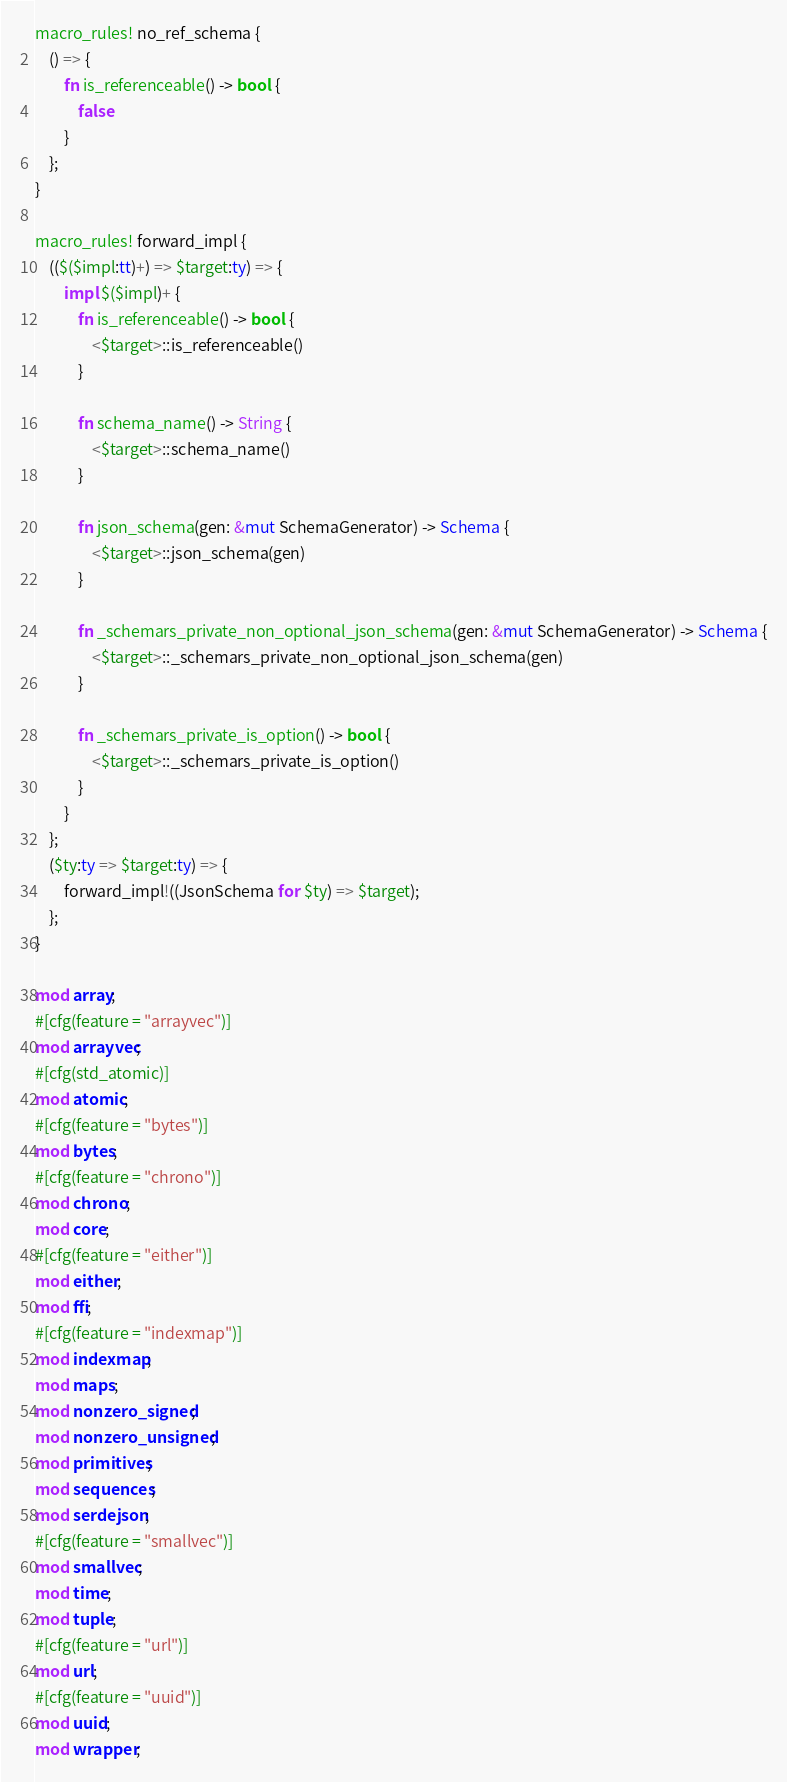<code> <loc_0><loc_0><loc_500><loc_500><_Rust_>macro_rules! no_ref_schema {
    () => {
        fn is_referenceable() -> bool {
            false
        }
    };
}

macro_rules! forward_impl {
    (($($impl:tt)+) => $target:ty) => {
        impl $($impl)+ {
            fn is_referenceable() -> bool {
                <$target>::is_referenceable()
            }

            fn schema_name() -> String {
                <$target>::schema_name()
            }

            fn json_schema(gen: &mut SchemaGenerator) -> Schema {
                <$target>::json_schema(gen)
            }

            fn _schemars_private_non_optional_json_schema(gen: &mut SchemaGenerator) -> Schema {
                <$target>::_schemars_private_non_optional_json_schema(gen)
            }

            fn _schemars_private_is_option() -> bool {
                <$target>::_schemars_private_is_option()
            }
        }
    };
    ($ty:ty => $target:ty) => {
        forward_impl!((JsonSchema for $ty) => $target);
    };
}

mod array;
#[cfg(feature = "arrayvec")]
mod arrayvec;
#[cfg(std_atomic)]
mod atomic;
#[cfg(feature = "bytes")]
mod bytes;
#[cfg(feature = "chrono")]
mod chrono;
mod core;
#[cfg(feature = "either")]
mod either;
mod ffi;
#[cfg(feature = "indexmap")]
mod indexmap;
mod maps;
mod nonzero_signed;
mod nonzero_unsigned;
mod primitives;
mod sequences;
mod serdejson;
#[cfg(feature = "smallvec")]
mod smallvec;
mod time;
mod tuple;
#[cfg(feature = "url")]
mod url;
#[cfg(feature = "uuid")]
mod uuid;
mod wrapper;
</code> 